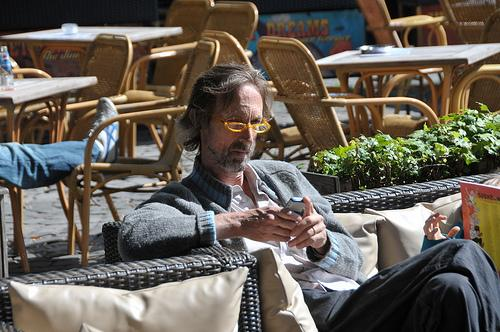Identify the main object and its color in the image along with any action it is performing. The man wearing a grey sweater is the main object, and he is looking at a cellphone. How is the man positioned and what kind of furniture is he using? The man is sitting with legs crossed on a grey couch, with one leg propped up on a brown chair. Count the number of objects on the table and list them. There are 4 objects on the table: a silver ashtray, a small glass candle holder, an empty bottle, and a jar. What is the physical orientation of the child's hand in the image, and what is it doing? The child's hand is outstretched, and it appears to be reaching for something. Mention the type of glasses the man is wearing and their distinctive feature. The man is wearing amber colored eyeglasses with a yellow tint. Describe the environment surrounding the grey patio sofa in the image. There is a leafy bush behind the grey patio sofa and a row of green plants nearby. Find and describe a small object placed on the table in the image. There is a small glass candle holder on the table. What type of footwear is the person in the image wearing? The person is wearing white sneakers with blue stripes. Provide a brief description of the facial features and accessories of the man in the image. The man has a grey beard and hair, and he's wearing hipster style yellow glasses. Describe an object with blue designs on it. blue designs on sneaker Is the man wearing blue jeans or any other pants color? Not visible or clear. Describe the man's leg position in the image. sitting with legs crossed, one leg propped up on a chair What is a notable feature about the man's beard? He has a grey beard. Can you spot the pink-colored sneaker with green stripes in the image? There is mention of a white sneaker with blue stripes, but there isn't any pink sneaker with green stripes in the image. Is the man wearing eyeglasses, and if so, what color are they?  Yes, he is wearing amber colored glasses. Describe the scene involving green plants and furniture. a row of green plants behind a grey patio sofa and a table surrounded by chairs Point out the location of the white pillow. on a chair What color are the sneakers in the vicinity? white with blue stripes Is there a black pillow instead of a white pillow on the couch? No, it's not mentioned in the image. What word is written in yellow and orange color? dreams Narrate the situation involving a man and his cellphone. a man looking at his cellphone with two hands holding it Which object is placed near a table and has a beverage context? empty soda bottle Can you identify a child's hand in the image? Yes, there is a small child's hand outstretched. Find an object related to reading present in the scene. part of the back cover of a child's book What is the man wearing on his upper body?  a grey sweater List any additional objects found near the gray couch. There is a white pillow on the couch and a brown chair nearby. Enumerate three objects found on a table in the scene. a silver ashtray, a small glass candle holder, and a jar What type of glasses is the man wearing? hipster style sun glasses Is there any furniture near the man in the image? Yes, a brown chair is behind the man. Does the man have short blond hair instead of grey hair? The man is described as having grey hair and grey beard, not short blond hair, so the instruction is misleading. Is the man wearing a bright red sweater while sitting on the grey couch? The instruction is misleading as the man is wearing a grey sweater, not a bright red one. 